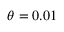Convert formula to latex. <formula><loc_0><loc_0><loc_500><loc_500>\theta = 0 . 0 1</formula> 